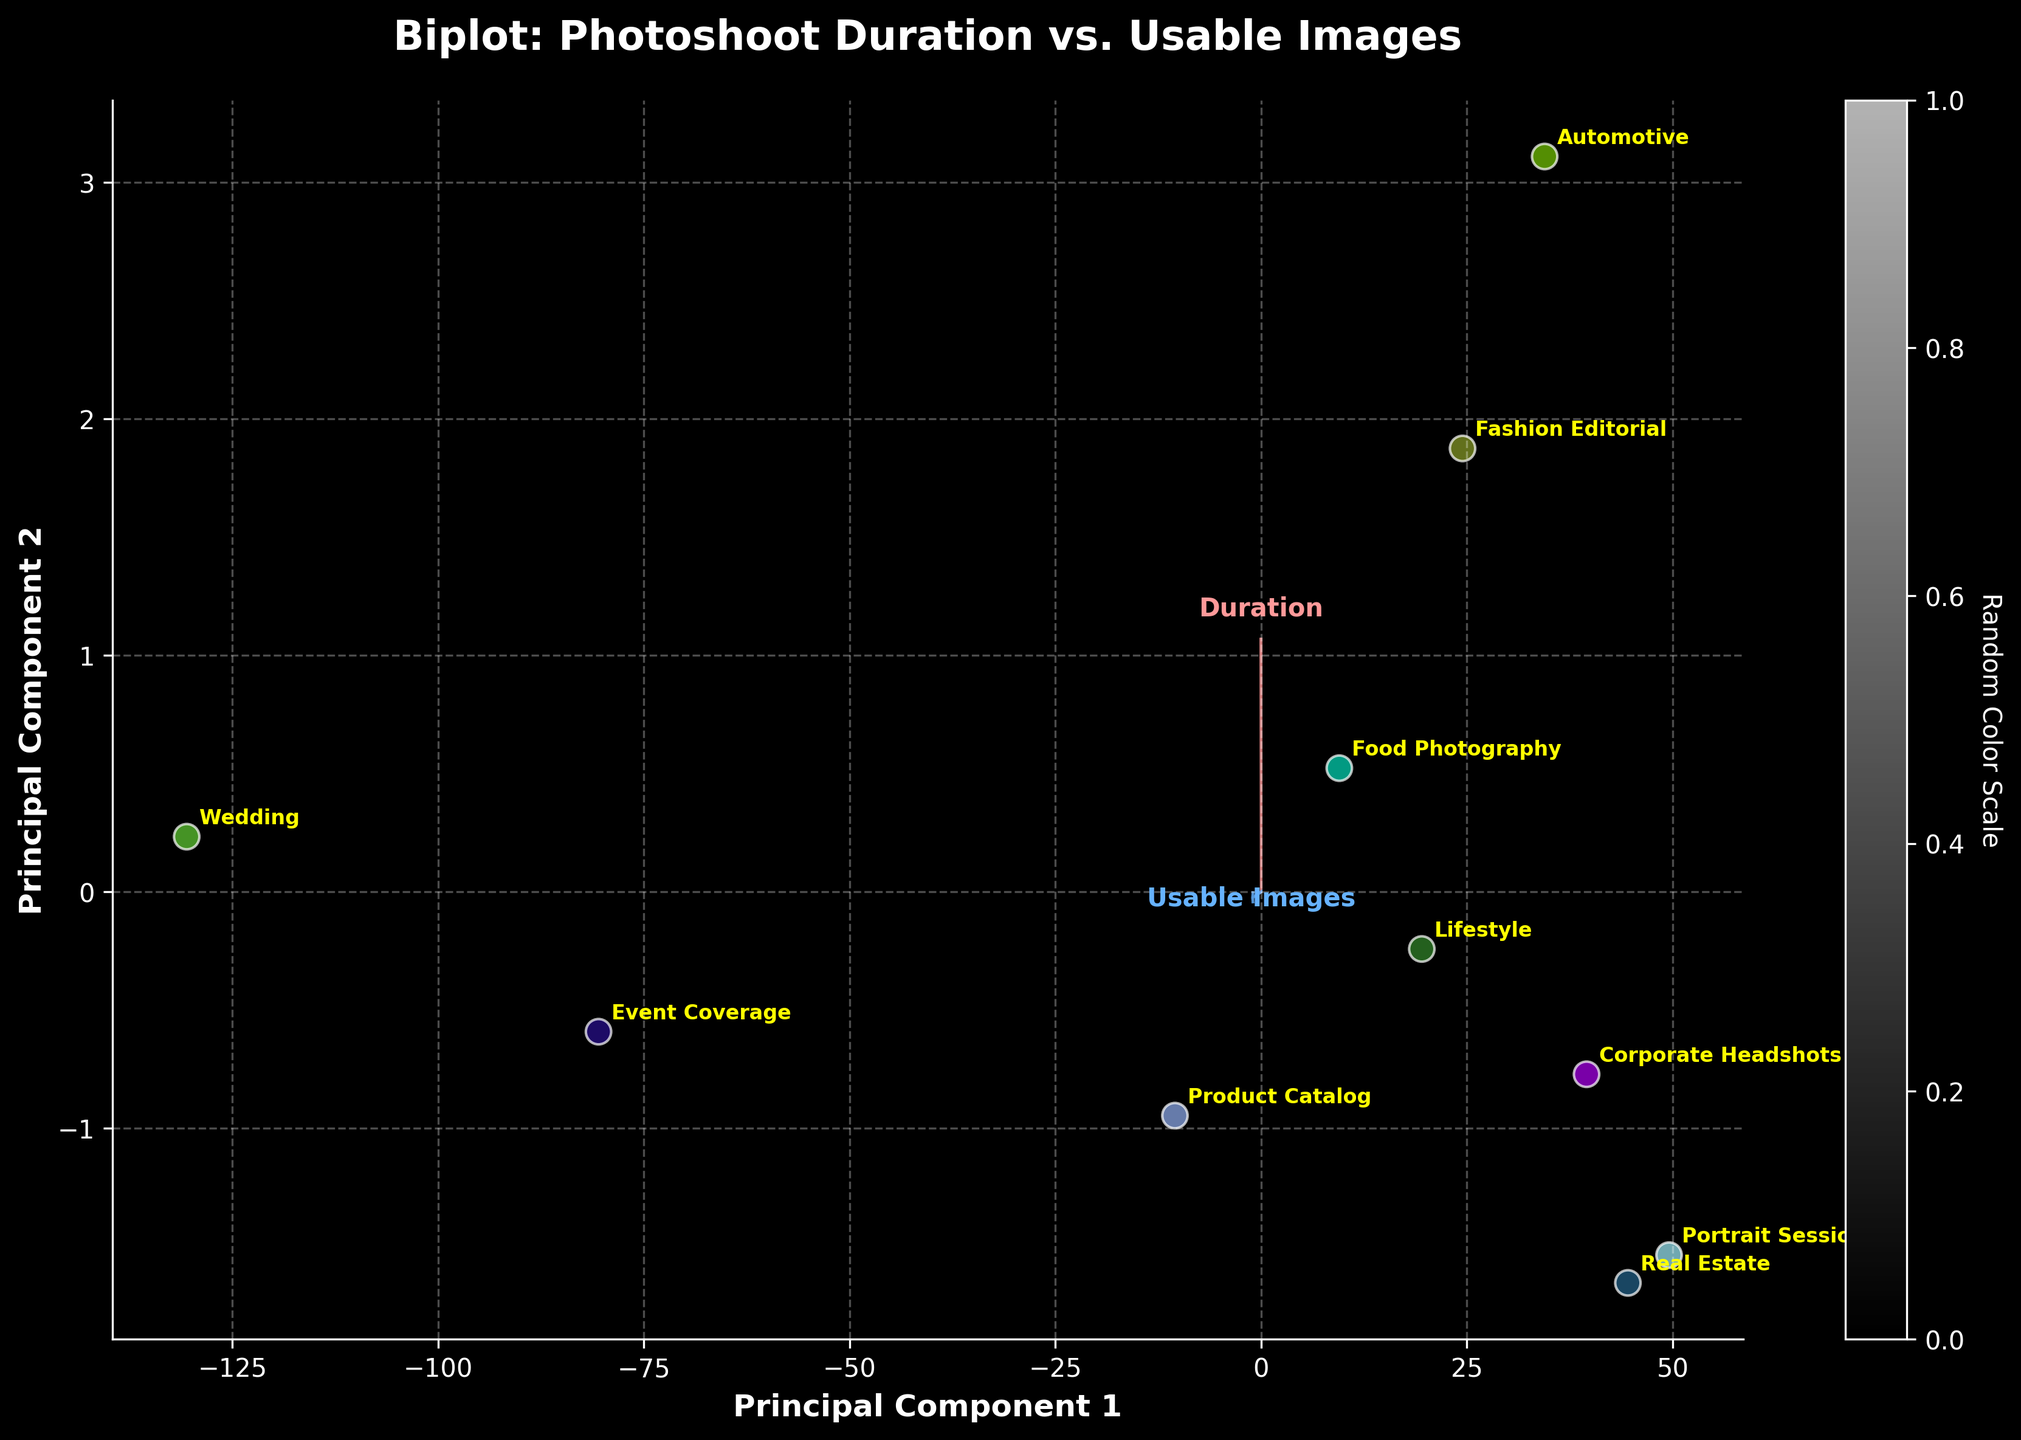Which photoshoot has the highest number of usable images? By looking at the figure, the data point corresponding to the Wedding photoshoot is farthest along the 'Usable Images' vector, indicating it has the highest number of usable images.
Answer: Wedding What are the names of the photoshoots that have a duration of less than 3 hours? The photoshoots with data points farthest to the left along the 'Duration' vector (indicating shorter durations) are "Real Estate" and "Portrait Session".
Answer: Real Estate, Portrait Session Which photoshoot has the shortest duration but produces a notable number of usable images? "Real Estate" and "Portrait Session" both have short durations, but between them, "Real Estate" has a higher number of usable images.
Answer: Real Estate What is the overall trend between photoshoot duration and the number of usable images? By observing the vectors for 'Duration' and 'Usable Images', there is a general positive trend where longer photoshoot durations tend to produce more usable images.
Answer: Positive Trend How many data points are there in total on the plot? By counting the number of labels or data points scattered on the plot, there are 10 photoshoots in total.
Answer: 10 Which photoshoot combines a long duration with a moderate number of usable images? The photoshoot labeled as "Automotive" has a longer duration but does not produce as many usable images as "Wedding" or "Event Coverage".
Answer: Automotive Does the Fashion Editorial photoshoot have more or fewer usable images than the Food Photography photoshoot? By comparing the positions of the data points for "Fashion Editorial" and "Food Photography", the former has fewer usable images than the latter.
Answer: Fewer Which photoshoot is closest to the center of the plot? The data point corresponding to "Corporate Headshots" is plotted near the center of the plot, indicating its values are closer to the mean for both duration and usable images.
Answer: Corporate Headshots How do Event Coverage and Wedding photoshoots compare in terms of usable images? Both "Event Coverage" and "Wedding" have high numbers of usable images, with "Wedding" having the highest number.
Answer: Wedding has more 